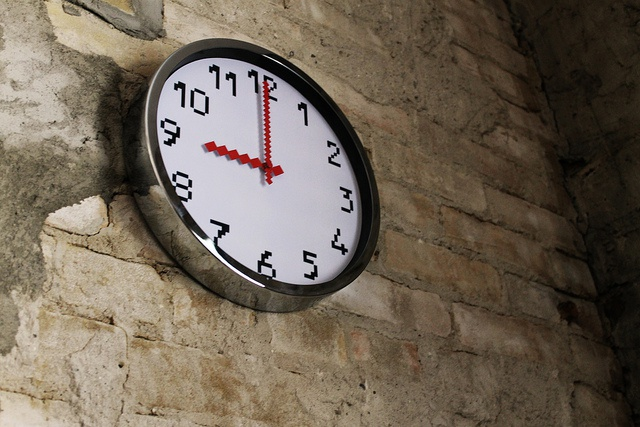Describe the objects in this image and their specific colors. I can see a clock in tan, lightgray, black, and darkgray tones in this image. 